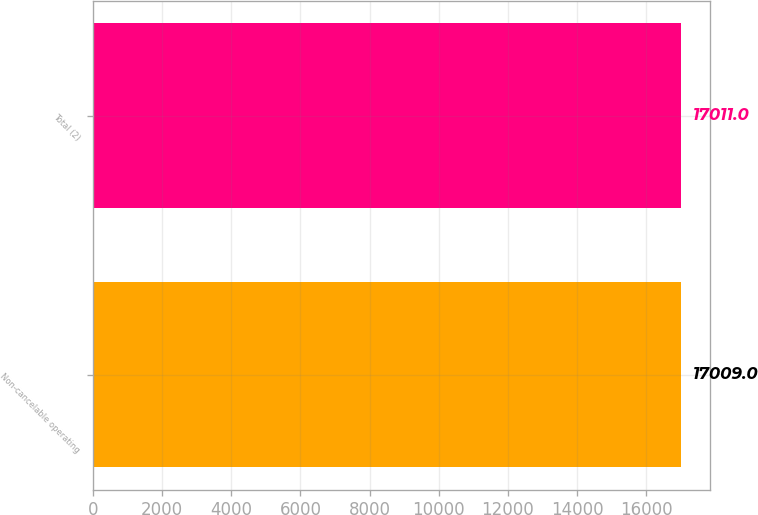<chart> <loc_0><loc_0><loc_500><loc_500><bar_chart><fcel>Non-cancelable operating<fcel>Total (2)<nl><fcel>17009<fcel>17011<nl></chart> 